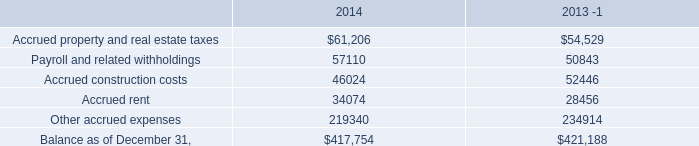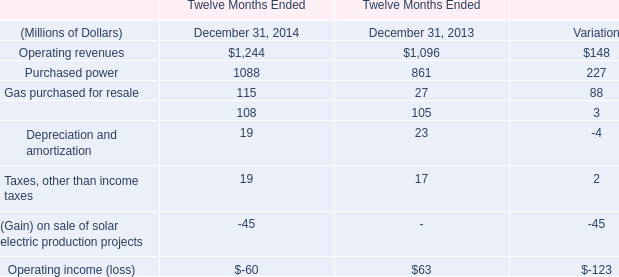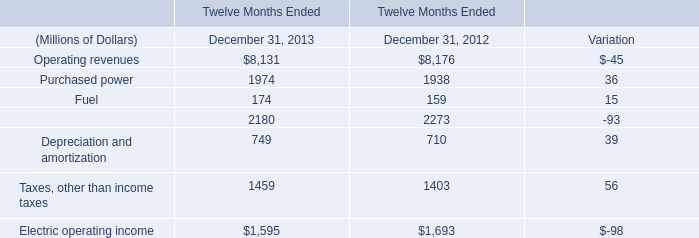what's the total amount of Accrued property and real estate taxes of 2014, and Purchased power of Twelve Months Ended December 31, 2014 ? 
Computations: (61206.0 + 1088.0)
Answer: 62294.0. 